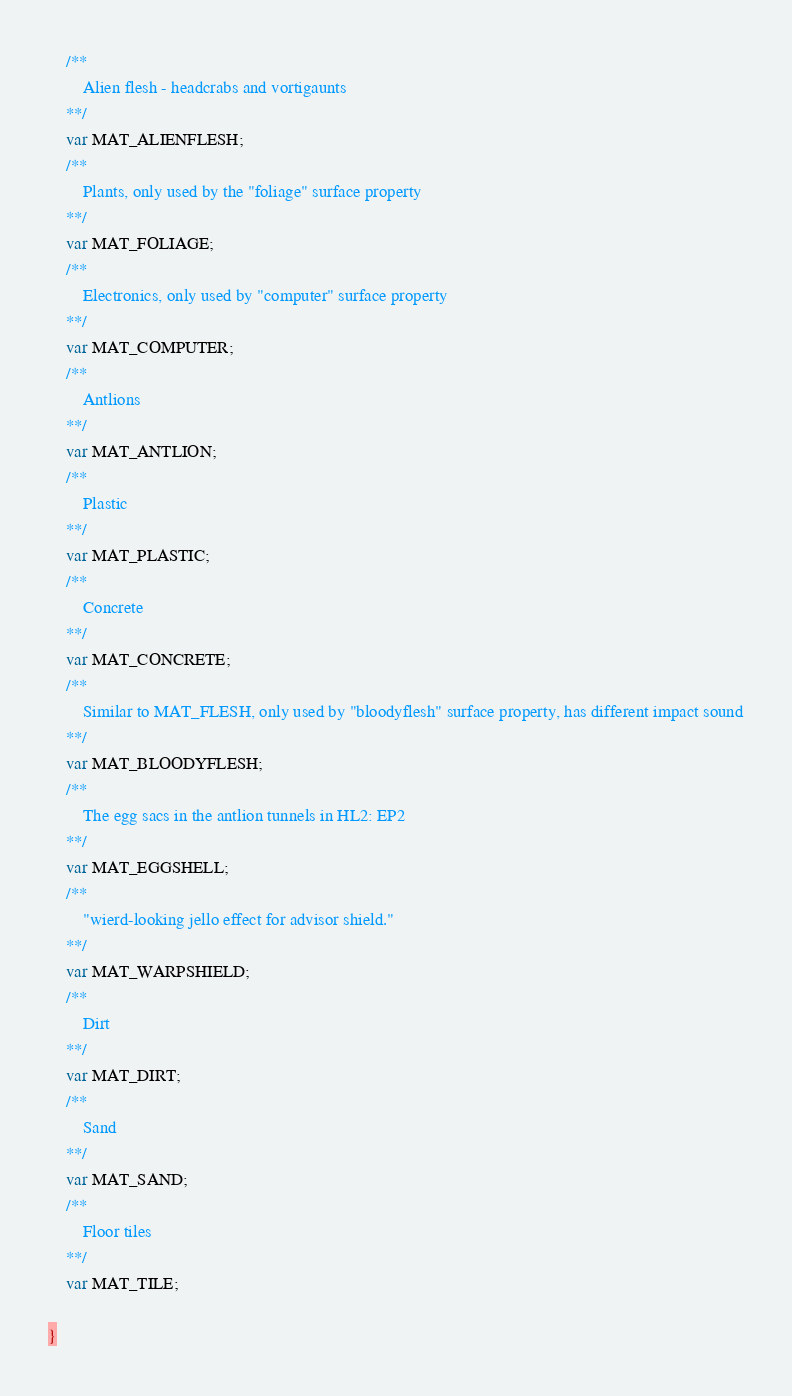Convert code to text. <code><loc_0><loc_0><loc_500><loc_500><_Haxe_>    /**
        Alien flesh - headcrabs and vortigaunts
    **/
    var MAT_ALIENFLESH;
    /**
        Plants, only used by the "foliage" surface property
    **/
    var MAT_FOLIAGE;
    /**
        Electronics, only used by "computer" surface property
    **/
    var MAT_COMPUTER;
    /**
        Antlions
    **/
    var MAT_ANTLION;
    /**
        Plastic
    **/
    var MAT_PLASTIC;
    /**
        Concrete
    **/
    var MAT_CONCRETE;
    /**
        Similar to MAT_FLESH, only used by "bloodyflesh" surface property, has different impact sound
    **/
    var MAT_BLOODYFLESH;
    /**
        The egg sacs in the antlion tunnels in HL2: EP2
    **/
    var MAT_EGGSHELL;
    /**
        "wierd-looking jello effect for advisor shield."
    **/
    var MAT_WARPSHIELD;
    /**
        Dirt
    **/
    var MAT_DIRT;
    /**
        Sand
    **/
    var MAT_SAND;
    /**
        Floor tiles
    **/
    var MAT_TILE;
    
}</code> 